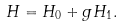Convert formula to latex. <formula><loc_0><loc_0><loc_500><loc_500>H = H _ { 0 } + g H _ { 1 } .</formula> 